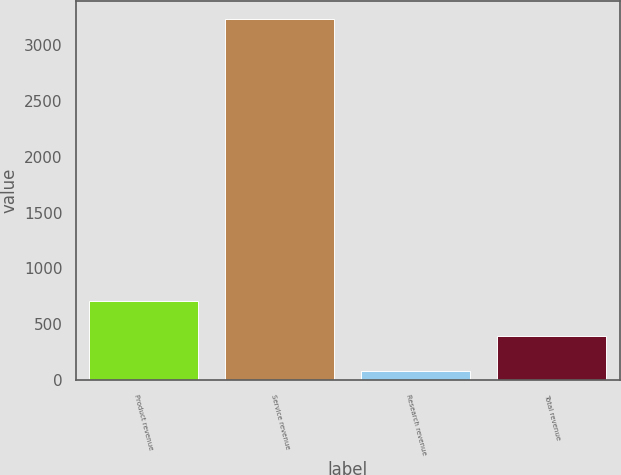<chart> <loc_0><loc_0><loc_500><loc_500><bar_chart><fcel>Product revenue<fcel>Service revenue<fcel>Research revenue<fcel>Total revenue<nl><fcel>709.2<fcel>3238<fcel>77<fcel>393.1<nl></chart> 